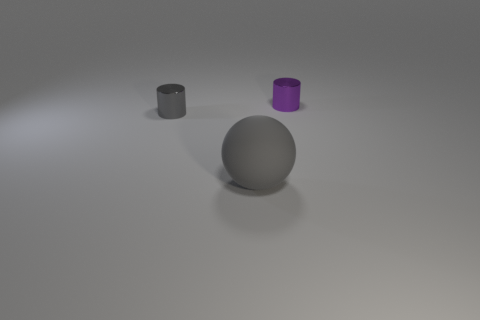The gray object right of the metal object left of the matte object is made of what material?
Offer a very short reply. Rubber. How many other things are the same shape as the big object?
Provide a succinct answer. 0. Do the tiny object to the left of the purple thing and the gray thing in front of the gray cylinder have the same shape?
Your answer should be compact. No. Is there any other thing that is the same material as the gray ball?
Offer a terse response. No. What is the material of the big gray thing?
Provide a succinct answer. Rubber. What is the material of the big gray ball on the left side of the purple metallic thing?
Offer a very short reply. Rubber. What size is the gray cylinder that is made of the same material as the small purple object?
Your answer should be compact. Small. What number of small things are either green matte cylinders or metallic cylinders?
Provide a short and direct response. 2. How big is the shiny cylinder that is in front of the small shiny object on the right side of the tiny cylinder left of the tiny purple shiny thing?
Give a very brief answer. Small. How many matte objects have the same size as the gray shiny object?
Your response must be concise. 0. 